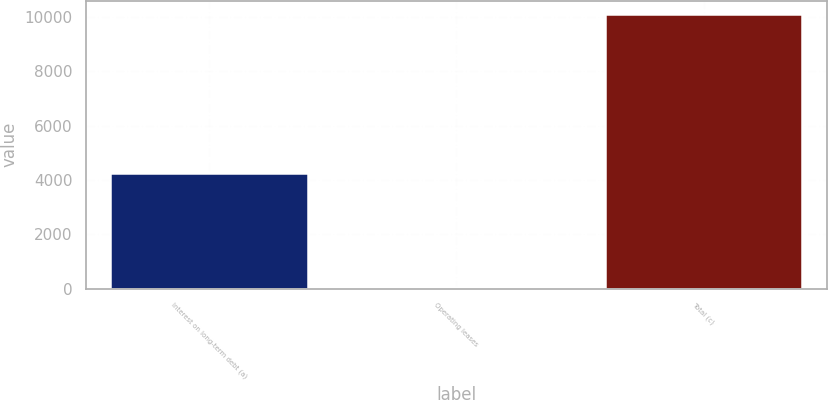<chart> <loc_0><loc_0><loc_500><loc_500><bar_chart><fcel>Interest on long-term debt (a)<fcel>Operating leases<fcel>Total (c)<nl><fcel>4241<fcel>73<fcel>10091<nl></chart> 